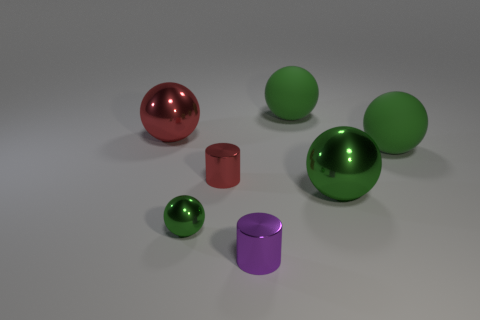What number of big brown cubes are there?
Provide a short and direct response. 0. Are the red thing right of the small metallic sphere and the red ball made of the same material?
Provide a succinct answer. Yes. Is there another purple metallic cylinder of the same size as the purple metallic cylinder?
Your answer should be very brief. No. There is a purple shiny thing; is it the same shape as the green shiny thing to the left of the tiny purple cylinder?
Provide a short and direct response. No. Are there any things behind the object behind the big thing on the left side of the red metal cylinder?
Provide a succinct answer. No. The red metal sphere has what size?
Make the answer very short. Large. How many other things are the same color as the tiny shiny ball?
Make the answer very short. 3. There is a large thing left of the small red metal thing; does it have the same shape as the large green metal object?
Offer a terse response. Yes. What is the color of the other object that is the same shape as the tiny red metallic thing?
Offer a very short reply. Purple. Is there anything else that has the same material as the red cylinder?
Your answer should be compact. Yes. 